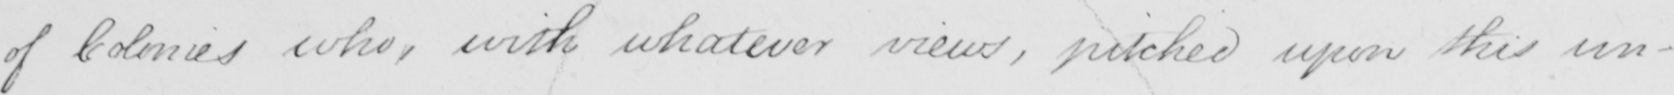What does this handwritten line say? of Colonies who , with whatever views , pitched upon this un- 